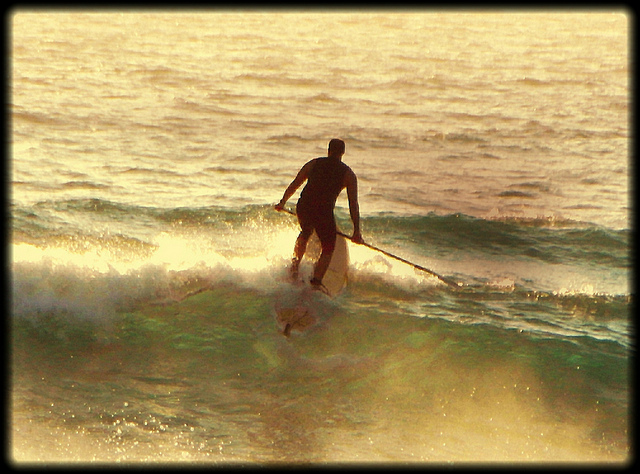What is the man doing in the image? The man in the image is stand-up paddleboarding on a wave in the ocean, gracefully maintaining balance as he navigates the water using a paddle. 